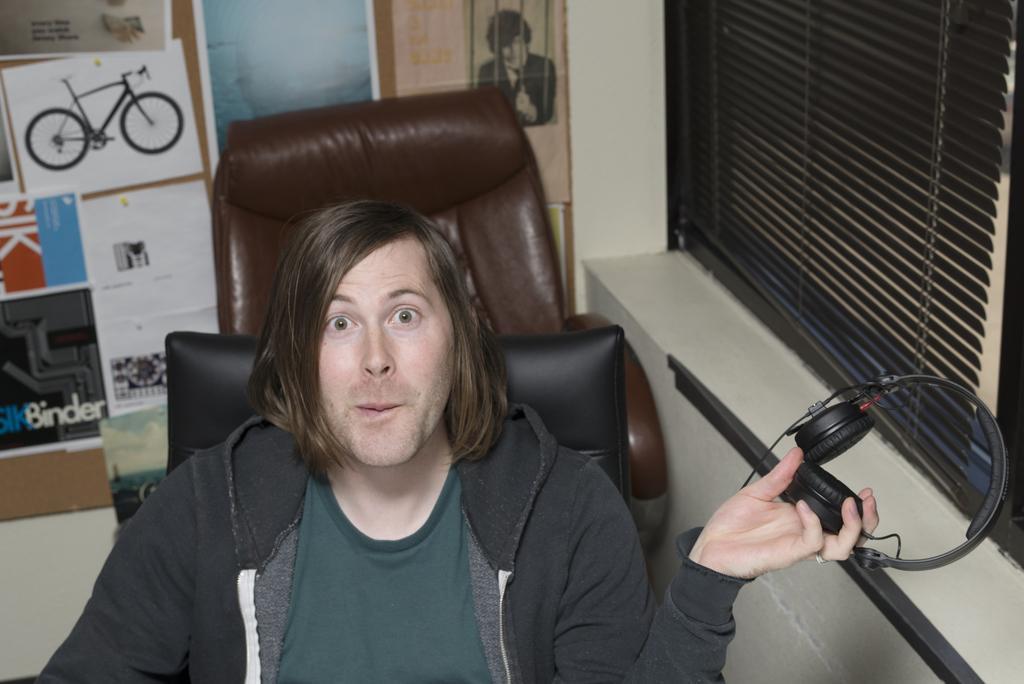Please provide a concise description of this image. In the center of the image a man is sitting on a chair and holding headset is his hand. In the background of the image we can see wallpapers, board, window. 